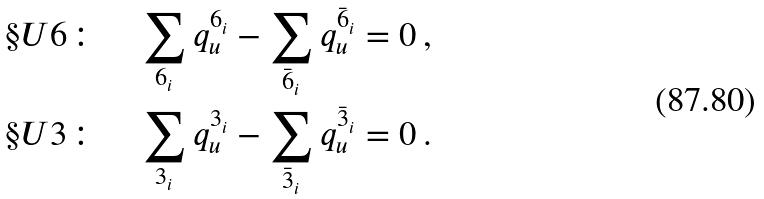Convert formula to latex. <formula><loc_0><loc_0><loc_500><loc_500>& \S U 6 \colon \quad \sum _ { 6 _ { i } } q ^ { 6 _ { i } } _ { u } - \sum _ { \bar { 6 } _ { i } } q ^ { \bar { 6 } _ { i } } _ { u } = 0 \, , \\ & \S U 3 \colon \quad \sum _ { 3 _ { i } } q ^ { 3 _ { i } } _ { u } - \sum _ { \bar { 3 } _ { i } } q ^ { \bar { 3 } _ { i } } _ { u } = 0 \, .</formula> 